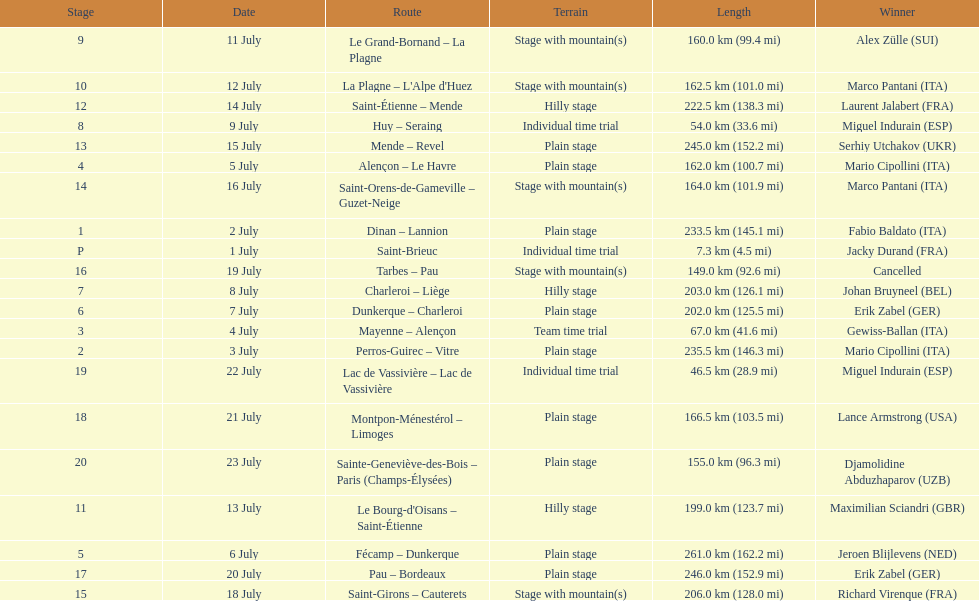Which routes were at least 100 km? Dinan - Lannion, Perros-Guirec - Vitre, Alençon - Le Havre, Fécamp - Dunkerque, Dunkerque - Charleroi, Charleroi - Liège, Le Grand-Bornand - La Plagne, La Plagne - L'Alpe d'Huez, Le Bourg-d'Oisans - Saint-Étienne, Saint-Étienne - Mende, Mende - Revel, Saint-Orens-de-Gameville - Guzet-Neige, Saint-Girons - Cauterets, Tarbes - Pau, Pau - Bordeaux, Montpon-Ménestérol - Limoges, Sainte-Geneviève-des-Bois - Paris (Champs-Élysées). 